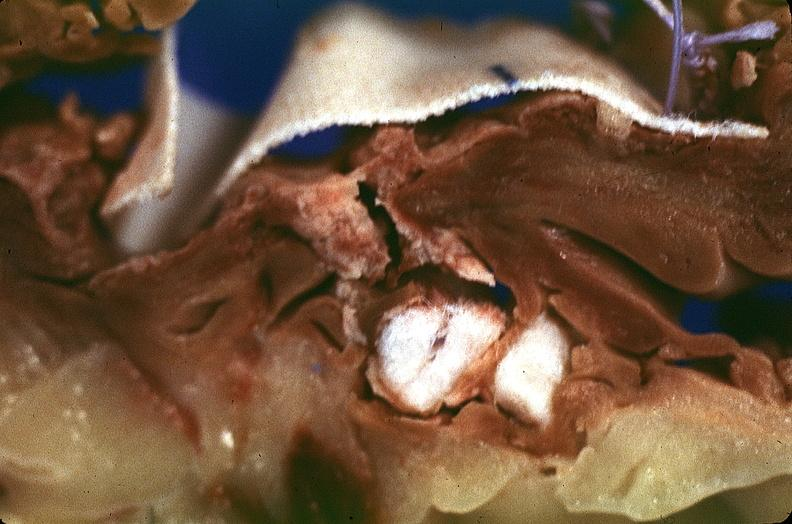what is present?
Answer the question using a single word or phrase. Cardiovascular 